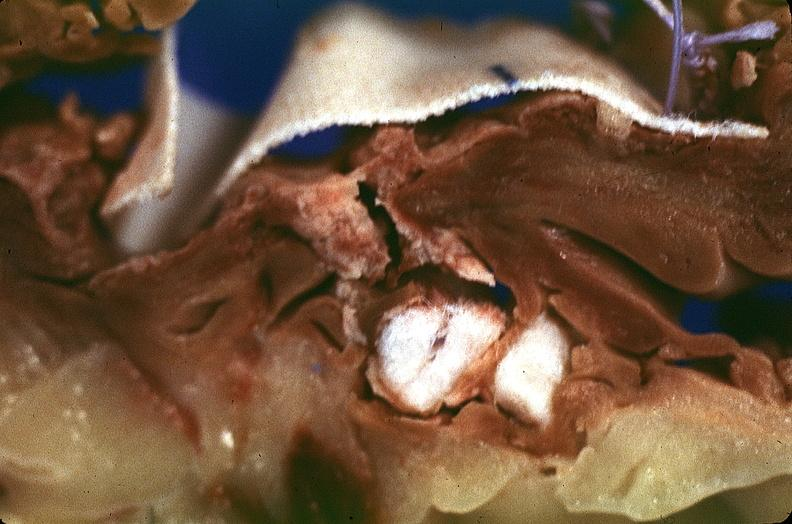what is present?
Answer the question using a single word or phrase. Cardiovascular 